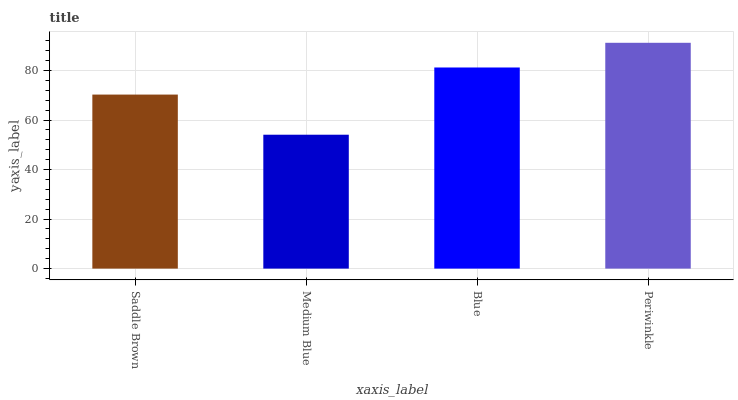Is Medium Blue the minimum?
Answer yes or no. Yes. Is Periwinkle the maximum?
Answer yes or no. Yes. Is Blue the minimum?
Answer yes or no. No. Is Blue the maximum?
Answer yes or no. No. Is Blue greater than Medium Blue?
Answer yes or no. Yes. Is Medium Blue less than Blue?
Answer yes or no. Yes. Is Medium Blue greater than Blue?
Answer yes or no. No. Is Blue less than Medium Blue?
Answer yes or no. No. Is Blue the high median?
Answer yes or no. Yes. Is Saddle Brown the low median?
Answer yes or no. Yes. Is Medium Blue the high median?
Answer yes or no. No. Is Blue the low median?
Answer yes or no. No. 